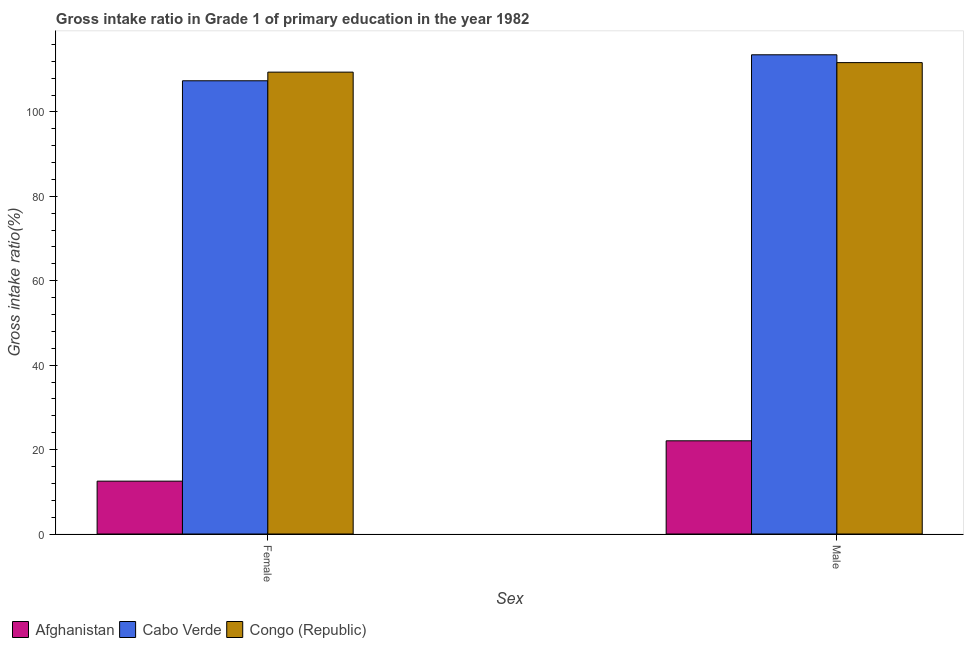How many different coloured bars are there?
Your answer should be very brief. 3. Are the number of bars per tick equal to the number of legend labels?
Offer a terse response. Yes. Are the number of bars on each tick of the X-axis equal?
Keep it short and to the point. Yes. How many bars are there on the 1st tick from the left?
Provide a short and direct response. 3. What is the label of the 1st group of bars from the left?
Offer a very short reply. Female. What is the gross intake ratio(male) in Afghanistan?
Ensure brevity in your answer.  22.08. Across all countries, what is the maximum gross intake ratio(female)?
Offer a very short reply. 109.42. Across all countries, what is the minimum gross intake ratio(female)?
Offer a terse response. 12.52. In which country was the gross intake ratio(male) maximum?
Ensure brevity in your answer.  Cabo Verde. In which country was the gross intake ratio(female) minimum?
Make the answer very short. Afghanistan. What is the total gross intake ratio(female) in the graph?
Provide a short and direct response. 229.32. What is the difference between the gross intake ratio(female) in Afghanistan and that in Congo (Republic)?
Your answer should be very brief. -96.9. What is the difference between the gross intake ratio(female) in Afghanistan and the gross intake ratio(male) in Cabo Verde?
Make the answer very short. -101.01. What is the average gross intake ratio(male) per country?
Provide a succinct answer. 82.43. What is the difference between the gross intake ratio(female) and gross intake ratio(male) in Congo (Republic)?
Keep it short and to the point. -2.26. In how many countries, is the gross intake ratio(female) greater than 32 %?
Your answer should be compact. 2. What is the ratio of the gross intake ratio(male) in Afghanistan to that in Congo (Republic)?
Ensure brevity in your answer.  0.2. Is the gross intake ratio(male) in Congo (Republic) less than that in Cabo Verde?
Your answer should be very brief. Yes. What does the 2nd bar from the left in Male represents?
Offer a terse response. Cabo Verde. What does the 2nd bar from the right in Male represents?
Provide a succinct answer. Cabo Verde. How many countries are there in the graph?
Give a very brief answer. 3. Are the values on the major ticks of Y-axis written in scientific E-notation?
Your answer should be very brief. No. Does the graph contain any zero values?
Your answer should be very brief. No. What is the title of the graph?
Make the answer very short. Gross intake ratio in Grade 1 of primary education in the year 1982. What is the label or title of the X-axis?
Your answer should be compact. Sex. What is the label or title of the Y-axis?
Offer a very short reply. Gross intake ratio(%). What is the Gross intake ratio(%) of Afghanistan in Female?
Provide a succinct answer. 12.52. What is the Gross intake ratio(%) of Cabo Verde in Female?
Your answer should be very brief. 107.37. What is the Gross intake ratio(%) in Congo (Republic) in Female?
Offer a terse response. 109.42. What is the Gross intake ratio(%) of Afghanistan in Male?
Your response must be concise. 22.08. What is the Gross intake ratio(%) of Cabo Verde in Male?
Your answer should be very brief. 113.53. What is the Gross intake ratio(%) of Congo (Republic) in Male?
Offer a terse response. 111.68. Across all Sex, what is the maximum Gross intake ratio(%) in Afghanistan?
Provide a short and direct response. 22.08. Across all Sex, what is the maximum Gross intake ratio(%) in Cabo Verde?
Keep it short and to the point. 113.53. Across all Sex, what is the maximum Gross intake ratio(%) of Congo (Republic)?
Ensure brevity in your answer.  111.68. Across all Sex, what is the minimum Gross intake ratio(%) in Afghanistan?
Provide a succinct answer. 12.52. Across all Sex, what is the minimum Gross intake ratio(%) in Cabo Verde?
Provide a short and direct response. 107.37. Across all Sex, what is the minimum Gross intake ratio(%) in Congo (Republic)?
Ensure brevity in your answer.  109.42. What is the total Gross intake ratio(%) in Afghanistan in the graph?
Offer a very short reply. 34.6. What is the total Gross intake ratio(%) in Cabo Verde in the graph?
Provide a short and direct response. 220.91. What is the total Gross intake ratio(%) in Congo (Republic) in the graph?
Your answer should be compact. 221.1. What is the difference between the Gross intake ratio(%) in Afghanistan in Female and that in Male?
Provide a short and direct response. -9.55. What is the difference between the Gross intake ratio(%) of Cabo Verde in Female and that in Male?
Ensure brevity in your answer.  -6.16. What is the difference between the Gross intake ratio(%) in Congo (Republic) in Female and that in Male?
Keep it short and to the point. -2.26. What is the difference between the Gross intake ratio(%) of Afghanistan in Female and the Gross intake ratio(%) of Cabo Verde in Male?
Your answer should be compact. -101.01. What is the difference between the Gross intake ratio(%) in Afghanistan in Female and the Gross intake ratio(%) in Congo (Republic) in Male?
Give a very brief answer. -99.15. What is the difference between the Gross intake ratio(%) in Cabo Verde in Female and the Gross intake ratio(%) in Congo (Republic) in Male?
Your response must be concise. -4.3. What is the average Gross intake ratio(%) of Afghanistan per Sex?
Your response must be concise. 17.3. What is the average Gross intake ratio(%) in Cabo Verde per Sex?
Offer a very short reply. 110.45. What is the average Gross intake ratio(%) of Congo (Republic) per Sex?
Ensure brevity in your answer.  110.55. What is the difference between the Gross intake ratio(%) in Afghanistan and Gross intake ratio(%) in Cabo Verde in Female?
Keep it short and to the point. -94.85. What is the difference between the Gross intake ratio(%) of Afghanistan and Gross intake ratio(%) of Congo (Republic) in Female?
Your response must be concise. -96.9. What is the difference between the Gross intake ratio(%) of Cabo Verde and Gross intake ratio(%) of Congo (Republic) in Female?
Provide a short and direct response. -2.05. What is the difference between the Gross intake ratio(%) in Afghanistan and Gross intake ratio(%) in Cabo Verde in Male?
Your response must be concise. -91.45. What is the difference between the Gross intake ratio(%) of Afghanistan and Gross intake ratio(%) of Congo (Republic) in Male?
Offer a terse response. -89.6. What is the difference between the Gross intake ratio(%) in Cabo Verde and Gross intake ratio(%) in Congo (Republic) in Male?
Offer a very short reply. 1.85. What is the ratio of the Gross intake ratio(%) of Afghanistan in Female to that in Male?
Keep it short and to the point. 0.57. What is the ratio of the Gross intake ratio(%) in Cabo Verde in Female to that in Male?
Keep it short and to the point. 0.95. What is the ratio of the Gross intake ratio(%) of Congo (Republic) in Female to that in Male?
Provide a succinct answer. 0.98. What is the difference between the highest and the second highest Gross intake ratio(%) in Afghanistan?
Give a very brief answer. 9.55. What is the difference between the highest and the second highest Gross intake ratio(%) in Cabo Verde?
Provide a succinct answer. 6.16. What is the difference between the highest and the second highest Gross intake ratio(%) in Congo (Republic)?
Your answer should be very brief. 2.26. What is the difference between the highest and the lowest Gross intake ratio(%) in Afghanistan?
Ensure brevity in your answer.  9.55. What is the difference between the highest and the lowest Gross intake ratio(%) of Cabo Verde?
Offer a terse response. 6.16. What is the difference between the highest and the lowest Gross intake ratio(%) of Congo (Republic)?
Your answer should be compact. 2.26. 